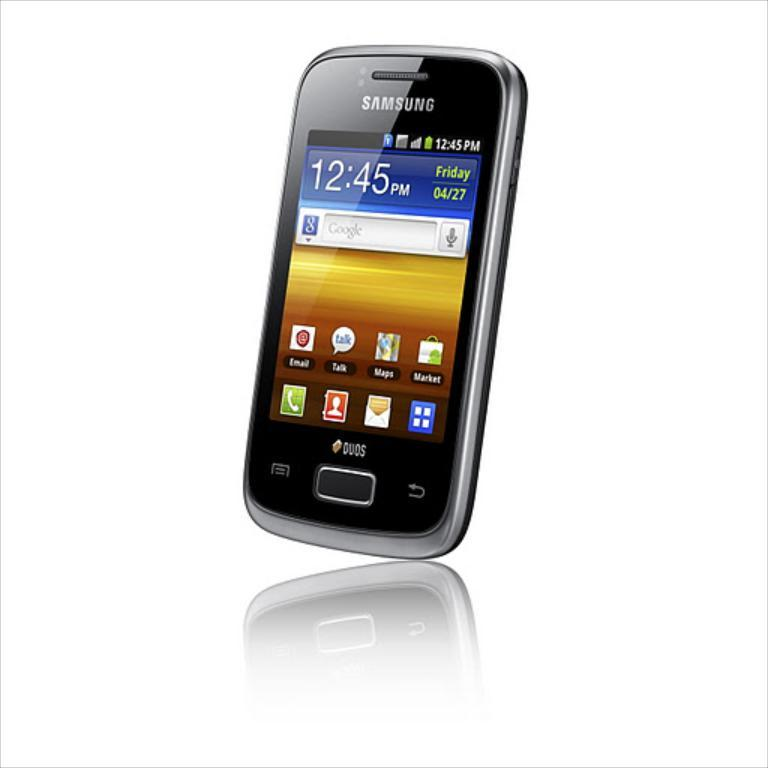<image>
Offer a succinct explanation of the picture presented. the screen of a samsung branded cell phone whose time reads 12:45. 